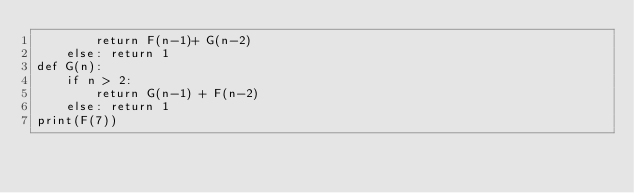<code> <loc_0><loc_0><loc_500><loc_500><_Python_>        return F(n-1)+ G(n-2)
    else: return 1
def G(n):
    if n > 2:
        return G(n-1) + F(n-2)
    else: return 1
print(F(7))</code> 